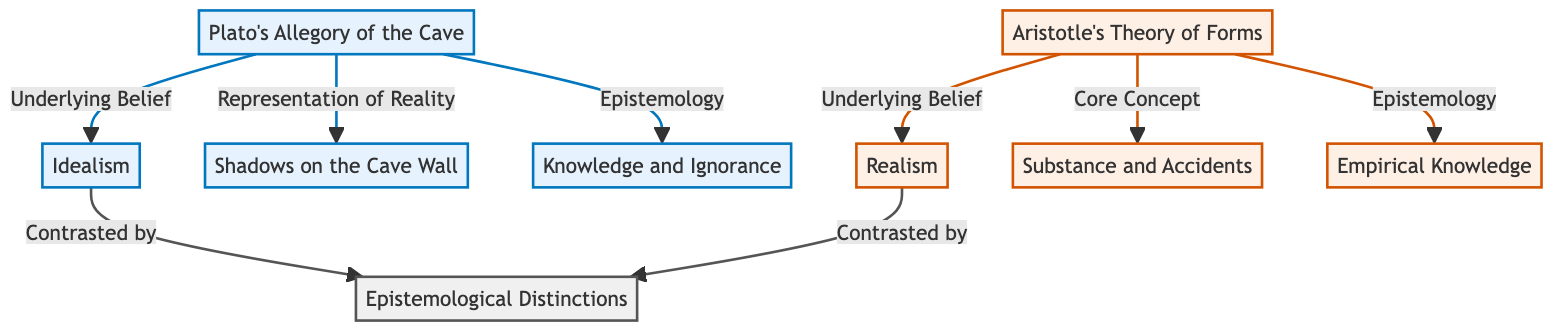What are the two main philosophies represented in this diagram? The diagram highlights Plato's Idealism and Aristotle's Realism as the two main philosophies, directly connected to their respective theories.
Answer: Idealism, Realism What is the concept linked with Plato's Allegory of the Cave regarding representation? The diagram indicates that "Shadows on the Cave Wall" represents the concept of representation within Plato’s Allegory of the Cave.
Answer: Shadows on the Cave Wall Which node relates to Aristotle's understanding of knowledge? The diagram shows that "Empirical Knowledge" is directly connected to Aristotle's Theory of Forms under the epistemology category.
Answer: Empirical Knowledge How many nodes are directly connected to Plato's Allegory of the Cave? There are three direct connections from Plato's Allegory of the Cave to the nodes: Idealism, Shadows on the Cave Wall, and Knowledge and Ignorance, totaling three.
Answer: 3 What is contrasted with Plato's Idealism in the diagram? The diagram indicates that philosophers' distinction is positioned as the contrasting idea to Plato's Idealism.
Answer: Epistemological Distinctions What underlying belief is associated with Aristotle's Theory of Forms? According to the diagram, the underlying belief associated with Aristotle's Theory of Forms is Realism.
Answer: Realism Which connection suggests a comparison between the epistemological approaches of Plato and Aristotle? The connections between both Plato's Knowledge and Ignorance and Aristotle's Empirical Knowledge suggest their respective epistemological approaches' comparison.
Answer: Epistemological Distinctions What connects the two main theories of Plato and Aristotle in this diagram? The connection based on their underlying beliefs (Idealism for Plato and Realism for Aristotle) signifies their comparative relationship in the context of this diagram.
Answer: Underlying Belief 